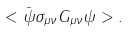Convert formula to latex. <formula><loc_0><loc_0><loc_500><loc_500>< \bar { \psi } \sigma _ { \mu \nu } G _ { \mu \nu } \psi > .</formula> 